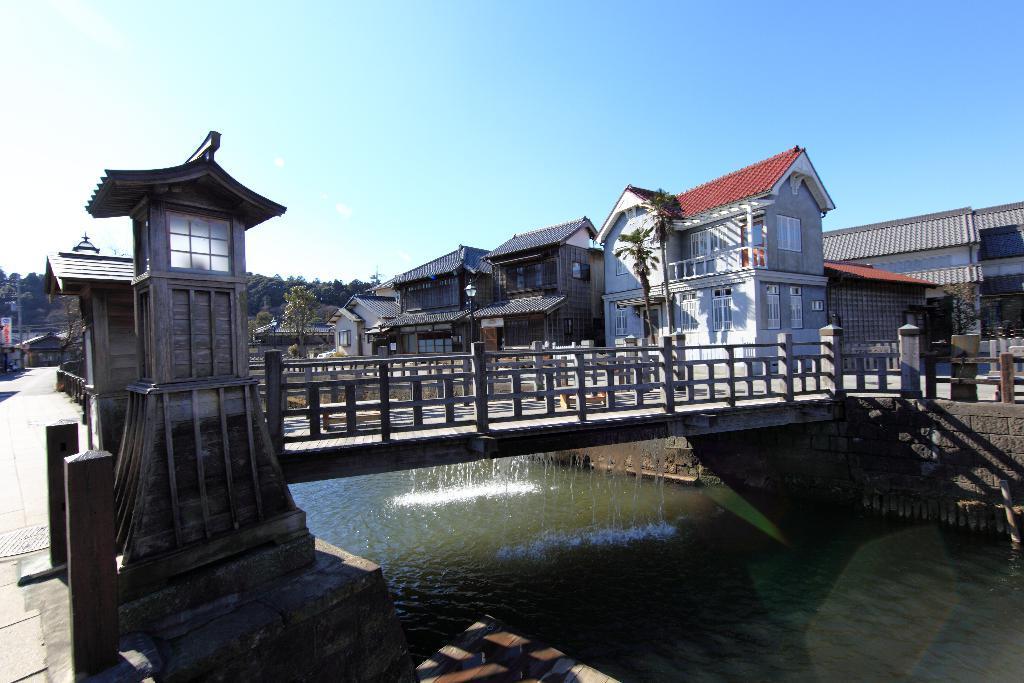Can you describe this image briefly? In this picture we can see a bridge, buildings, trees, electric poles, banner and under this bridge we can see water and we can see sky in the background. 